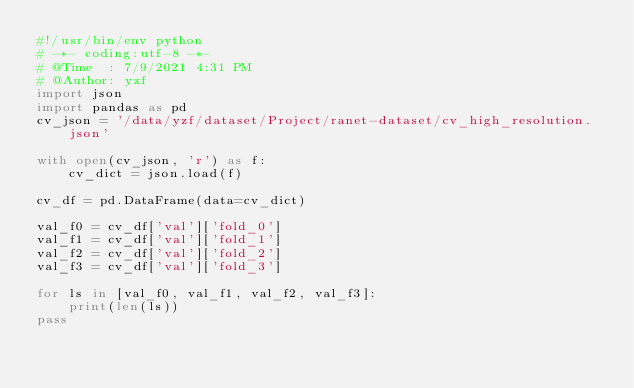Convert code to text. <code><loc_0><loc_0><loc_500><loc_500><_Python_>#!/usr/bin/env python
# -*- coding:utf-8 -*-
# @Time  : 7/9/2021 4:31 PM
# @Author: yzf
import json
import pandas as pd
cv_json = '/data/yzf/dataset/Project/ranet-dataset/cv_high_resolution.json'

with open(cv_json, 'r') as f:
    cv_dict = json.load(f)

cv_df = pd.DataFrame(data=cv_dict)

val_f0 = cv_df['val']['fold_0']
val_f1 = cv_df['val']['fold_1']
val_f2 = cv_df['val']['fold_2']
val_f3 = cv_df['val']['fold_3']

for ls in [val_f0, val_f1, val_f2, val_f3]:
    print(len(ls))
pass</code> 